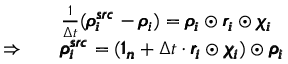<formula> <loc_0><loc_0><loc_500><loc_500>\begin{array} { r l } & { \frac { 1 } { \Delta t } ( \pm b { \rho _ { i } ^ { s r c } } - \pm b { \rho _ { i } } ) = \pm b { \rho _ { i } } \odot \pm b { r _ { i } } \odot \pm b { \chi _ { i } } } \\ { \Rightarrow \quad } & { \pm b { \rho _ { i } ^ { s r c } } = ( \pm b { 1 _ { n } } + \Delta t \cdot \pm b { r _ { i } } \odot \pm b { \chi _ { i } } ) \odot \pm b { \rho _ { i } } } \end{array}</formula> 